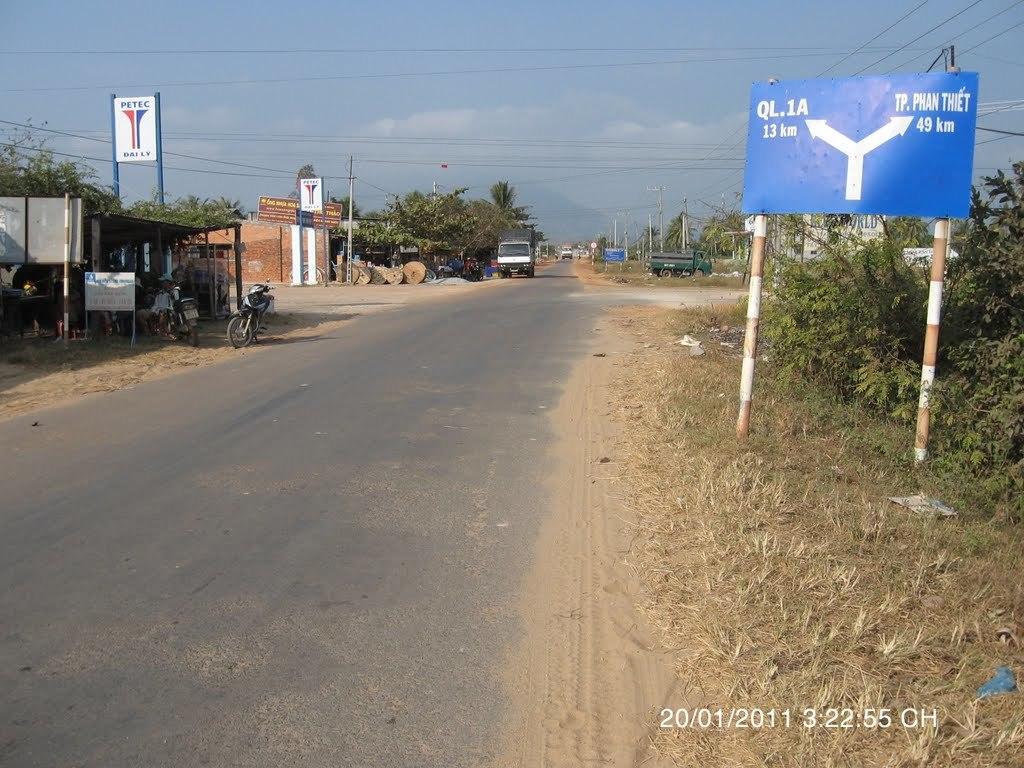What date was this taken?
Your answer should be very brief. 20/01/2011. 